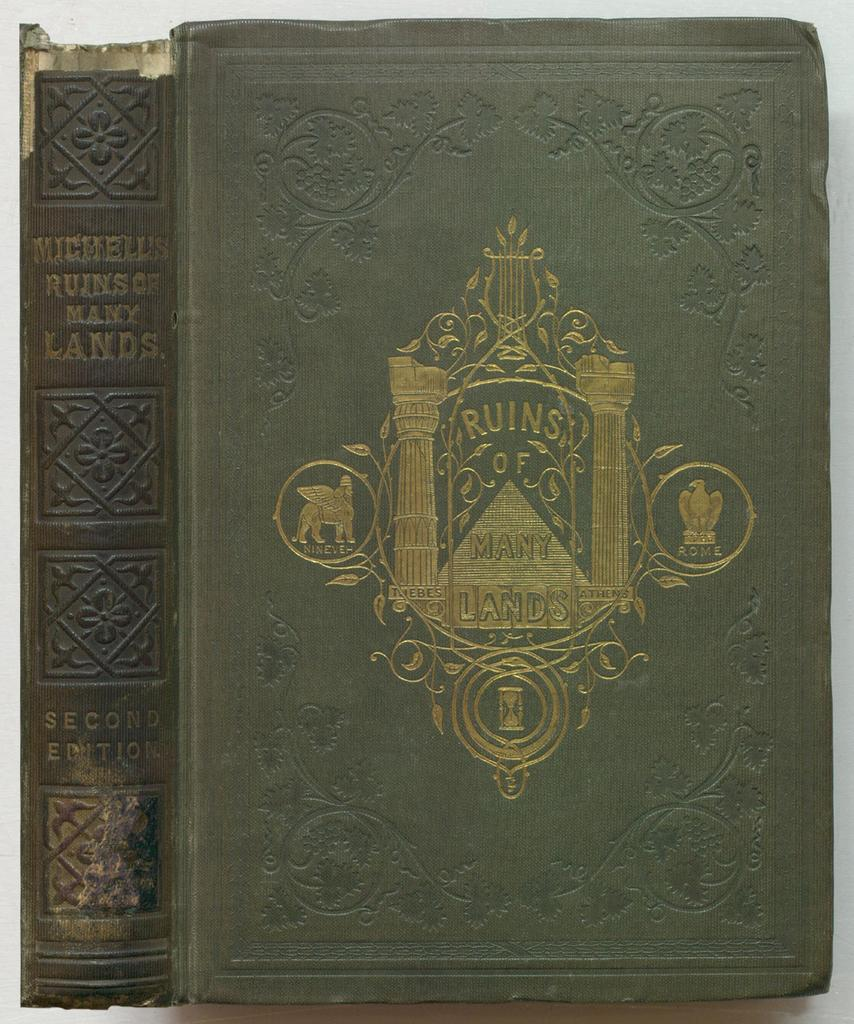<image>
Present a compact description of the photo's key features. a book titled 'ruins of many lands' the second edition 